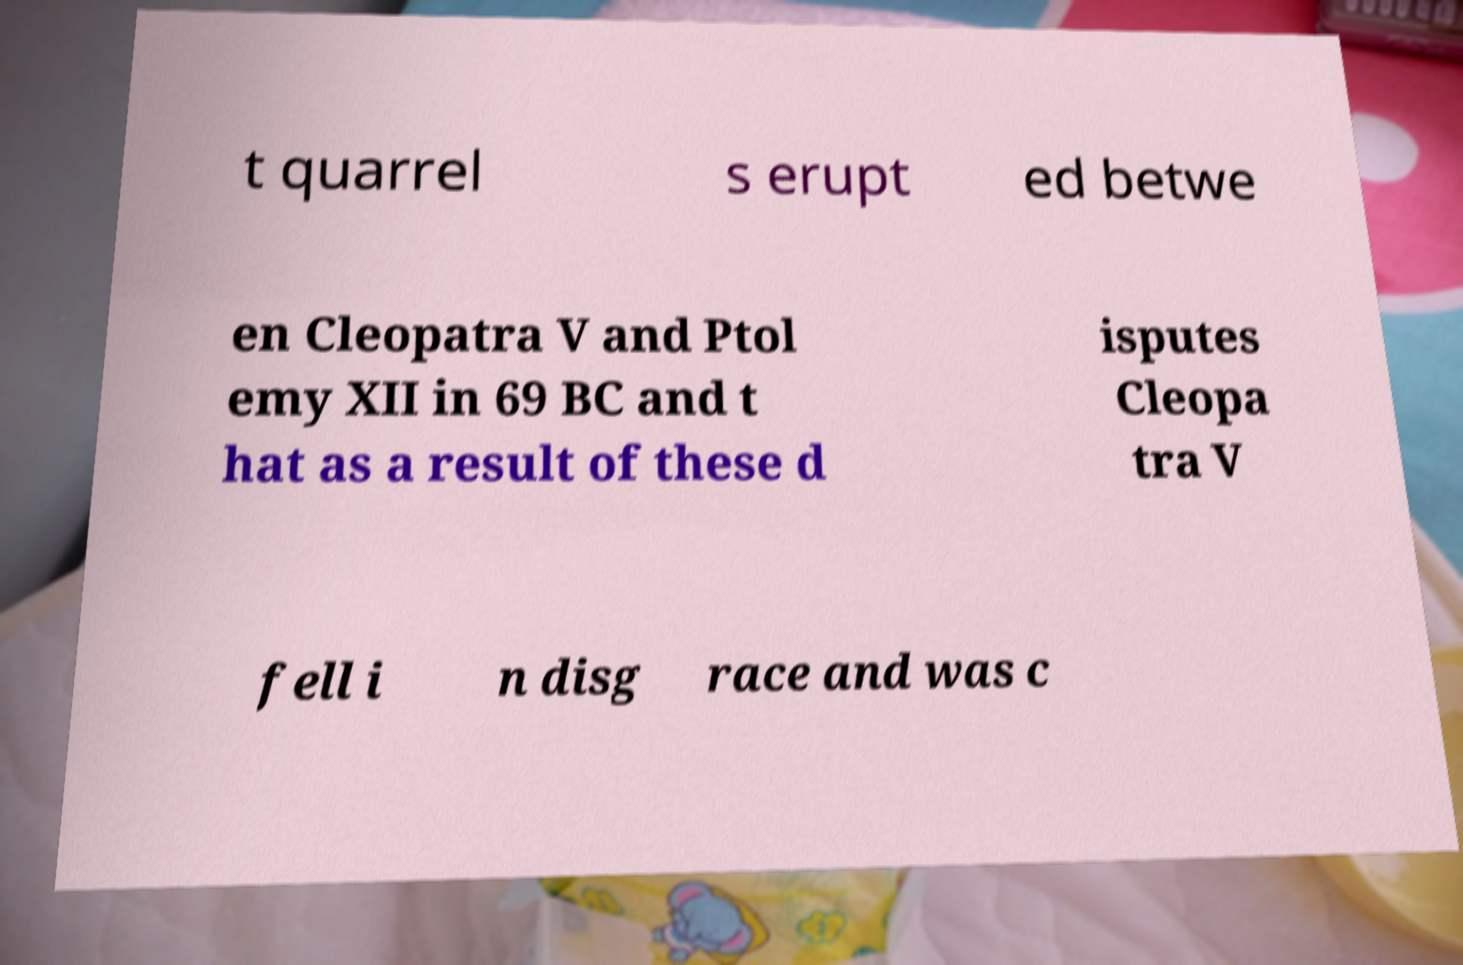Can you accurately transcribe the text from the provided image for me? t quarrel s erupt ed betwe en Cleopatra V and Ptol emy XII in 69 BC and t hat as a result of these d isputes Cleopa tra V fell i n disg race and was c 